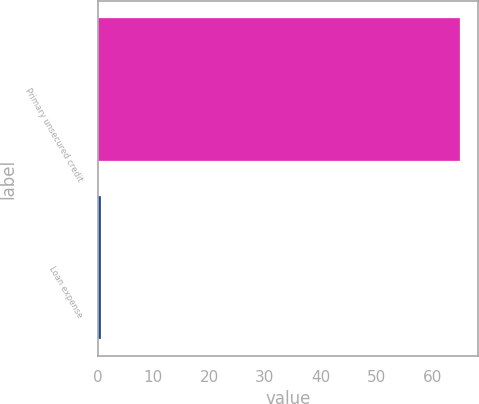<chart> <loc_0><loc_0><loc_500><loc_500><bar_chart><fcel>Primary unsecured credit<fcel>Loan expense<nl><fcel>65<fcel>0.64<nl></chart> 